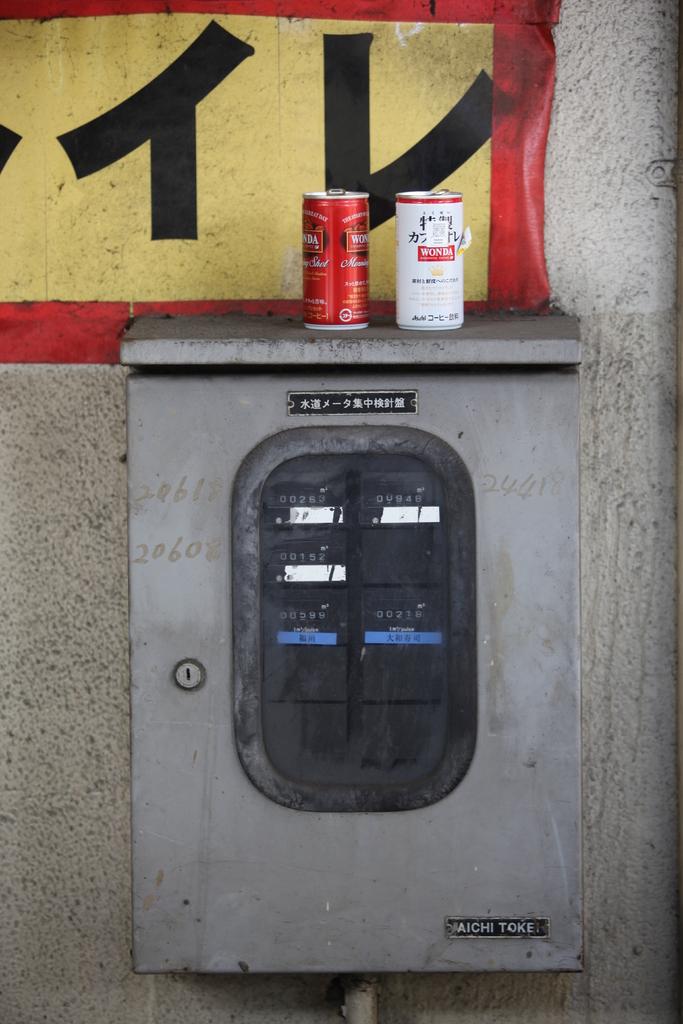What does it say on the bottom of the fuse box in the right?
Offer a terse response. Aichi toke. What is the reading on the top left of the meter?
Provide a short and direct response. 263. 